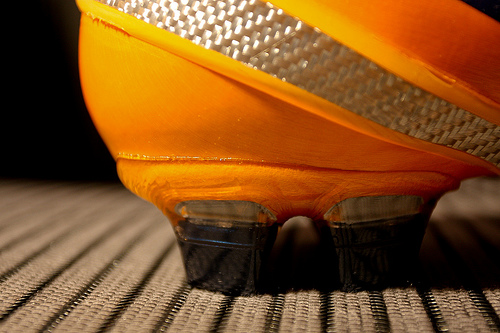<image>
Is there a shoe above the ground? Yes. The shoe is positioned above the ground in the vertical space, higher up in the scene. 